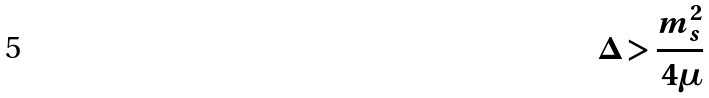Convert formula to latex. <formula><loc_0><loc_0><loc_500><loc_500>\Delta > \frac { m _ { s } ^ { 2 } } { 4 \mu }</formula> 